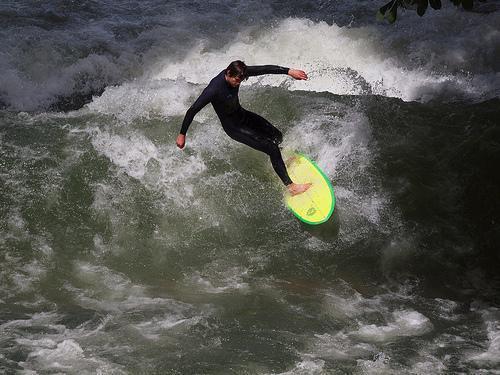How many surfers are shown?
Give a very brief answer. 1. 